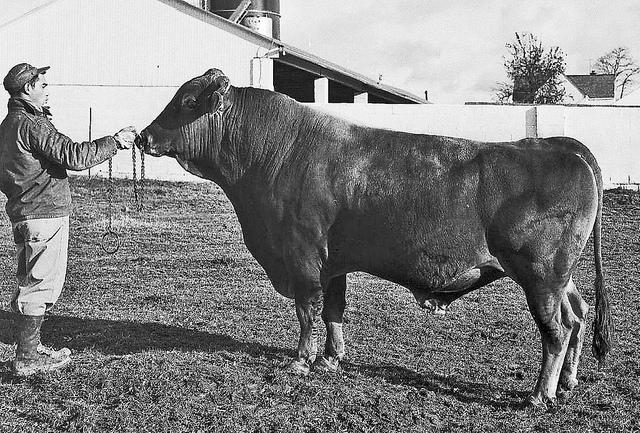What is this man doing?
Quick response, please. Feeding cow. Is this cow full-grown?
Give a very brief answer. Yes. What is in the man's hand?
Give a very brief answer. Chain. What is this man holding?
Quick response, please. Chain. 